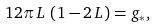Convert formula to latex. <formula><loc_0><loc_0><loc_500><loc_500>1 2 \pi \, L \, \left ( 1 - 2 \, L \right ) & = g _ { \ast } ,</formula> 